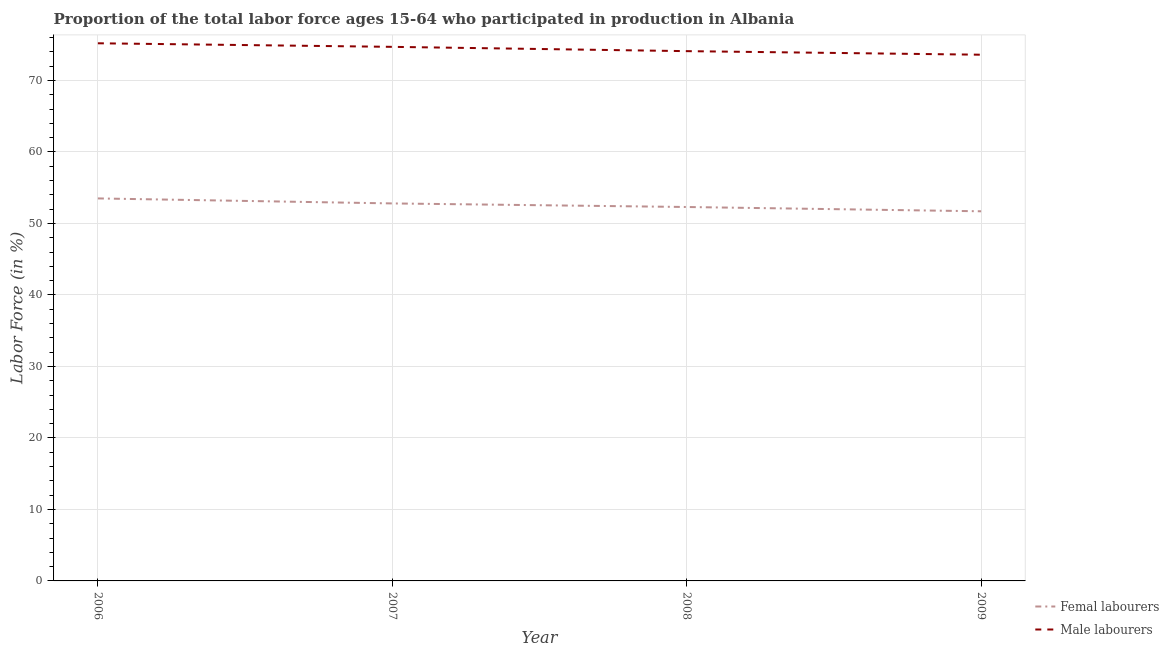What is the percentage of male labour force in 2006?
Provide a short and direct response. 75.2. Across all years, what is the maximum percentage of male labour force?
Offer a very short reply. 75.2. Across all years, what is the minimum percentage of female labor force?
Offer a very short reply. 51.7. In which year was the percentage of female labor force maximum?
Offer a very short reply. 2006. What is the total percentage of male labour force in the graph?
Offer a very short reply. 297.6. What is the difference between the percentage of male labour force in 2008 and that in 2009?
Offer a very short reply. 0.5. What is the difference between the percentage of female labor force in 2006 and the percentage of male labour force in 2007?
Give a very brief answer. -21.2. What is the average percentage of male labour force per year?
Your response must be concise. 74.4. In the year 2009, what is the difference between the percentage of male labour force and percentage of female labor force?
Ensure brevity in your answer.  21.9. What is the ratio of the percentage of female labor force in 2006 to that in 2007?
Your response must be concise. 1.01. What is the difference between the highest and the second highest percentage of female labor force?
Your answer should be very brief. 0.7. What is the difference between the highest and the lowest percentage of male labour force?
Give a very brief answer. 1.6. In how many years, is the percentage of male labour force greater than the average percentage of male labour force taken over all years?
Provide a succinct answer. 2. How many years are there in the graph?
Provide a short and direct response. 4. What is the difference between two consecutive major ticks on the Y-axis?
Your response must be concise. 10. What is the title of the graph?
Offer a terse response. Proportion of the total labor force ages 15-64 who participated in production in Albania. Does "Private creditors" appear as one of the legend labels in the graph?
Provide a short and direct response. No. What is the label or title of the X-axis?
Provide a short and direct response. Year. What is the label or title of the Y-axis?
Make the answer very short. Labor Force (in %). What is the Labor Force (in %) of Femal labourers in 2006?
Offer a terse response. 53.5. What is the Labor Force (in %) in Male labourers in 2006?
Your answer should be compact. 75.2. What is the Labor Force (in %) in Femal labourers in 2007?
Your answer should be very brief. 52.8. What is the Labor Force (in %) of Male labourers in 2007?
Your answer should be very brief. 74.7. What is the Labor Force (in %) of Femal labourers in 2008?
Give a very brief answer. 52.3. What is the Labor Force (in %) in Male labourers in 2008?
Keep it short and to the point. 74.1. What is the Labor Force (in %) of Femal labourers in 2009?
Ensure brevity in your answer.  51.7. What is the Labor Force (in %) in Male labourers in 2009?
Offer a terse response. 73.6. Across all years, what is the maximum Labor Force (in %) of Femal labourers?
Ensure brevity in your answer.  53.5. Across all years, what is the maximum Labor Force (in %) in Male labourers?
Give a very brief answer. 75.2. Across all years, what is the minimum Labor Force (in %) in Femal labourers?
Keep it short and to the point. 51.7. Across all years, what is the minimum Labor Force (in %) in Male labourers?
Ensure brevity in your answer.  73.6. What is the total Labor Force (in %) in Femal labourers in the graph?
Keep it short and to the point. 210.3. What is the total Labor Force (in %) in Male labourers in the graph?
Your answer should be compact. 297.6. What is the difference between the Labor Force (in %) in Femal labourers in 2006 and that in 2007?
Ensure brevity in your answer.  0.7. What is the difference between the Labor Force (in %) of Femal labourers in 2006 and that in 2009?
Make the answer very short. 1.8. What is the difference between the Labor Force (in %) of Male labourers in 2006 and that in 2009?
Keep it short and to the point. 1.6. What is the difference between the Labor Force (in %) in Male labourers in 2007 and that in 2008?
Offer a terse response. 0.6. What is the difference between the Labor Force (in %) in Femal labourers in 2007 and that in 2009?
Your response must be concise. 1.1. What is the difference between the Labor Force (in %) in Femal labourers in 2006 and the Labor Force (in %) in Male labourers in 2007?
Ensure brevity in your answer.  -21.2. What is the difference between the Labor Force (in %) in Femal labourers in 2006 and the Labor Force (in %) in Male labourers in 2008?
Offer a terse response. -20.6. What is the difference between the Labor Force (in %) in Femal labourers in 2006 and the Labor Force (in %) in Male labourers in 2009?
Give a very brief answer. -20.1. What is the difference between the Labor Force (in %) in Femal labourers in 2007 and the Labor Force (in %) in Male labourers in 2008?
Give a very brief answer. -21.3. What is the difference between the Labor Force (in %) of Femal labourers in 2007 and the Labor Force (in %) of Male labourers in 2009?
Your response must be concise. -20.8. What is the difference between the Labor Force (in %) in Femal labourers in 2008 and the Labor Force (in %) in Male labourers in 2009?
Provide a short and direct response. -21.3. What is the average Labor Force (in %) in Femal labourers per year?
Offer a terse response. 52.58. What is the average Labor Force (in %) in Male labourers per year?
Ensure brevity in your answer.  74.4. In the year 2006, what is the difference between the Labor Force (in %) of Femal labourers and Labor Force (in %) of Male labourers?
Offer a very short reply. -21.7. In the year 2007, what is the difference between the Labor Force (in %) of Femal labourers and Labor Force (in %) of Male labourers?
Keep it short and to the point. -21.9. In the year 2008, what is the difference between the Labor Force (in %) in Femal labourers and Labor Force (in %) in Male labourers?
Provide a succinct answer. -21.8. In the year 2009, what is the difference between the Labor Force (in %) of Femal labourers and Labor Force (in %) of Male labourers?
Your answer should be compact. -21.9. What is the ratio of the Labor Force (in %) in Femal labourers in 2006 to that in 2007?
Give a very brief answer. 1.01. What is the ratio of the Labor Force (in %) of Femal labourers in 2006 to that in 2008?
Your answer should be compact. 1.02. What is the ratio of the Labor Force (in %) in Male labourers in 2006 to that in 2008?
Offer a very short reply. 1.01. What is the ratio of the Labor Force (in %) in Femal labourers in 2006 to that in 2009?
Make the answer very short. 1.03. What is the ratio of the Labor Force (in %) of Male labourers in 2006 to that in 2009?
Offer a very short reply. 1.02. What is the ratio of the Labor Force (in %) of Femal labourers in 2007 to that in 2008?
Your response must be concise. 1.01. What is the ratio of the Labor Force (in %) of Male labourers in 2007 to that in 2008?
Offer a terse response. 1.01. What is the ratio of the Labor Force (in %) in Femal labourers in 2007 to that in 2009?
Keep it short and to the point. 1.02. What is the ratio of the Labor Force (in %) of Male labourers in 2007 to that in 2009?
Your response must be concise. 1.01. What is the ratio of the Labor Force (in %) of Femal labourers in 2008 to that in 2009?
Offer a terse response. 1.01. What is the ratio of the Labor Force (in %) of Male labourers in 2008 to that in 2009?
Provide a short and direct response. 1.01. What is the difference between the highest and the lowest Labor Force (in %) of Male labourers?
Ensure brevity in your answer.  1.6. 